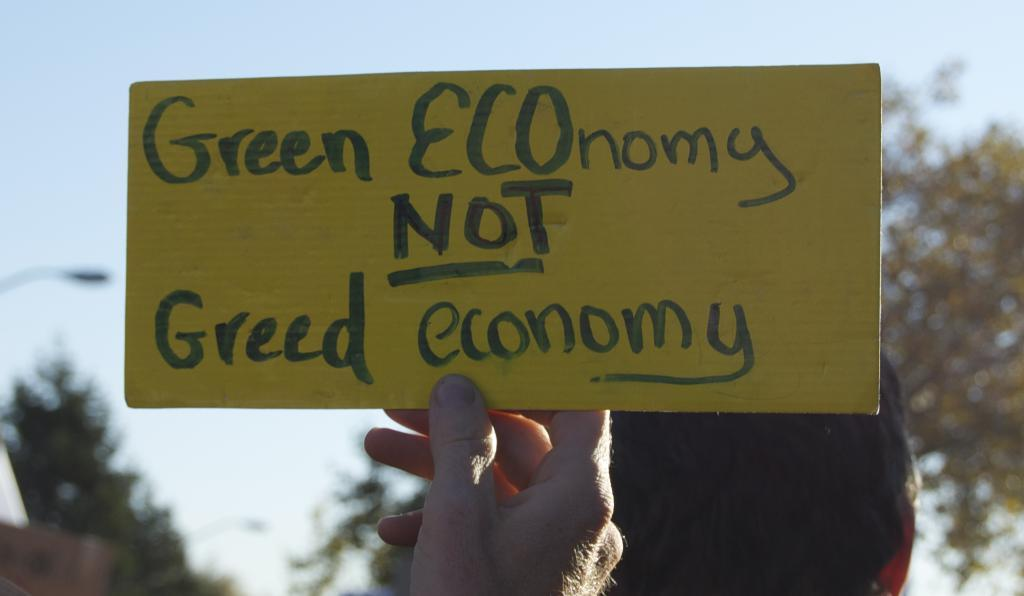What is present on the surface in the image? There is a sheet in the image. What part of a person can be seen in the image? A human hand is visible in the image. What can be seen in the background of the image? The sky is visible in the image. What type of natural vegetation is present in the image? There are trees in the image. What is the drainage rate of the water in the image? There is no water or drainage system present in the image, so it is not possible to determine the drainage rate. 